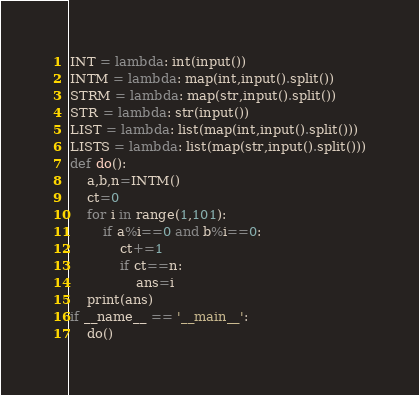<code> <loc_0><loc_0><loc_500><loc_500><_Python_>INT = lambda: int(input())
INTM = lambda: map(int,input().split())
STRM = lambda: map(str,input().split())
STR = lambda: str(input())
LIST = lambda: list(map(int,input().split()))
LISTS = lambda: list(map(str,input().split()))
def do():
    a,b,n=INTM()
    ct=0
    for i in range(1,101):
        if a%i==0 and b%i==0:
            ct+=1
            if ct==n:
                ans=i
    print(ans)
if __name__ == '__main__':
    do()</code> 